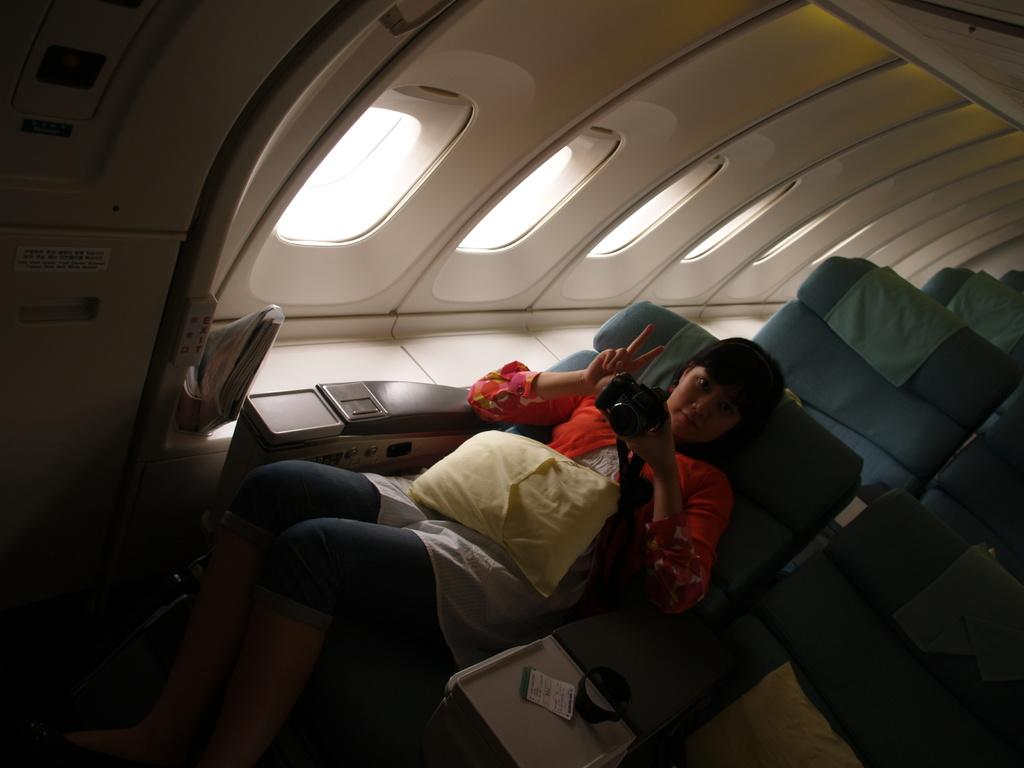What is the setting of the image? The image is taken inside a vehicle. Who is present in the image? There is a woman sitting on a chair. What is the woman holding in the image? The woman is holding a camera. How many chairs are visible in the image? There are chairs in the vehicle. What feature allows for visibility outside the vehicle? There are windows in the vehicle. What type of growth can be seen on the camera in the image? There is no growth visible on the camera in the image. Can you fold the windows in the vehicle to create more space? The windows in the vehicle cannot be folded, as they are fixed features for visibility. 